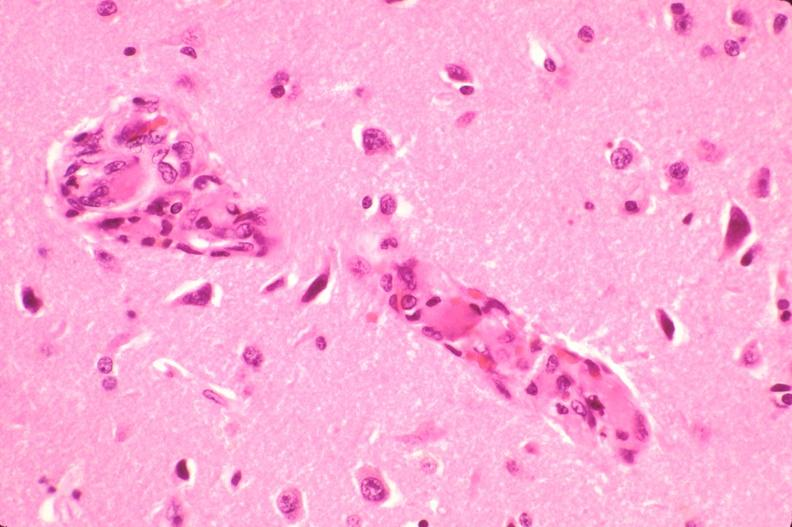what is present?
Answer the question using a single word or phrase. Nervous 